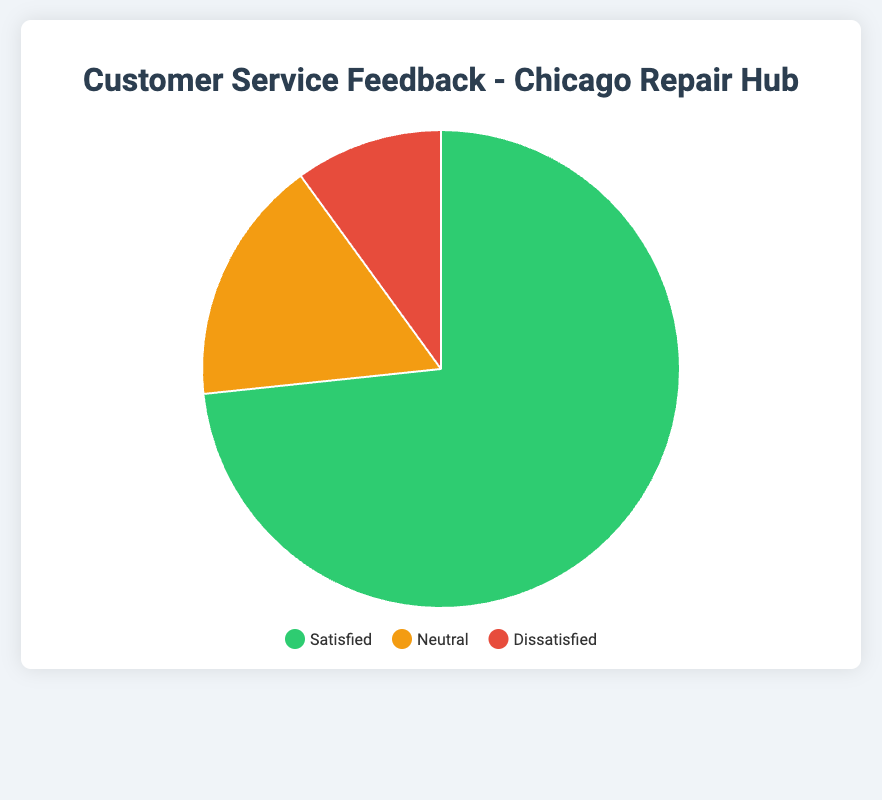What is the total number of feedback responses for Chicago Repair Hub? Add the number of Satisfied, Neutral, and Dissatisfied responses: 220 (Satisfied) + 50 (Neutral) + 30 (Dissatisfied) = 300.
Answer: 300 What percentage of customers were satisfied at the Chicago Repair Hub? The number of satisfied responses is 220. To find the percentage: (220/300) * 100 = 73.33%.
Answer: 73.33% How does the number of neutral responses compare to the number of dissatisfied responses at Chicago Repair Hub? There are 50 neutral responses and 30 dissatisfied responses. Since 50 is greater than 30, there are more neutral responses than dissatisfied ones.
Answer: More neutral responses What is the ratio of satisfied to dissatisfied customers at the Chicago Repair Hub? The number of satisfied customers is 220 and dissatisfied customers is 30. The ratio is 220:30 which simplifies to 22:3.
Answer: 22:3 Which category has the least number of responses for Chicago Repair Hub? Dissatisfied has 30 responses, which is fewer than Satisfied (220) and Neutral (50). Hence, Dissatisfied is the category with the least responses.
Answer: Dissatisfied What is the difference in the number of satisfied and neutral responses at the Chicago Repair Hub? Subtract the number of neutral responses from the number of satisfied responses: 220 (Satisfied) - 50 (Neutral) = 170.
Answer: 170 If there were 10 more dissatisfied responses, what would the new percentage of satisfied responses be? The new total responses would be 310 (300 + 10). The number of satisfied responses remains 220. So, (220/310) * 100 = 70.97%.
Answer: 70.97% How much larger is the satisfied segment compared to the dissatisfied segment in percentage points at Chicago Repair Hub? Calculate the percentage for each: (220/300) * 100 = 73.33% for Satisfied and (30/300) * 100 = 10% for Dissatisfied. The difference is 73.33% - 10% = 63.33%.
Answer: 63.33% 